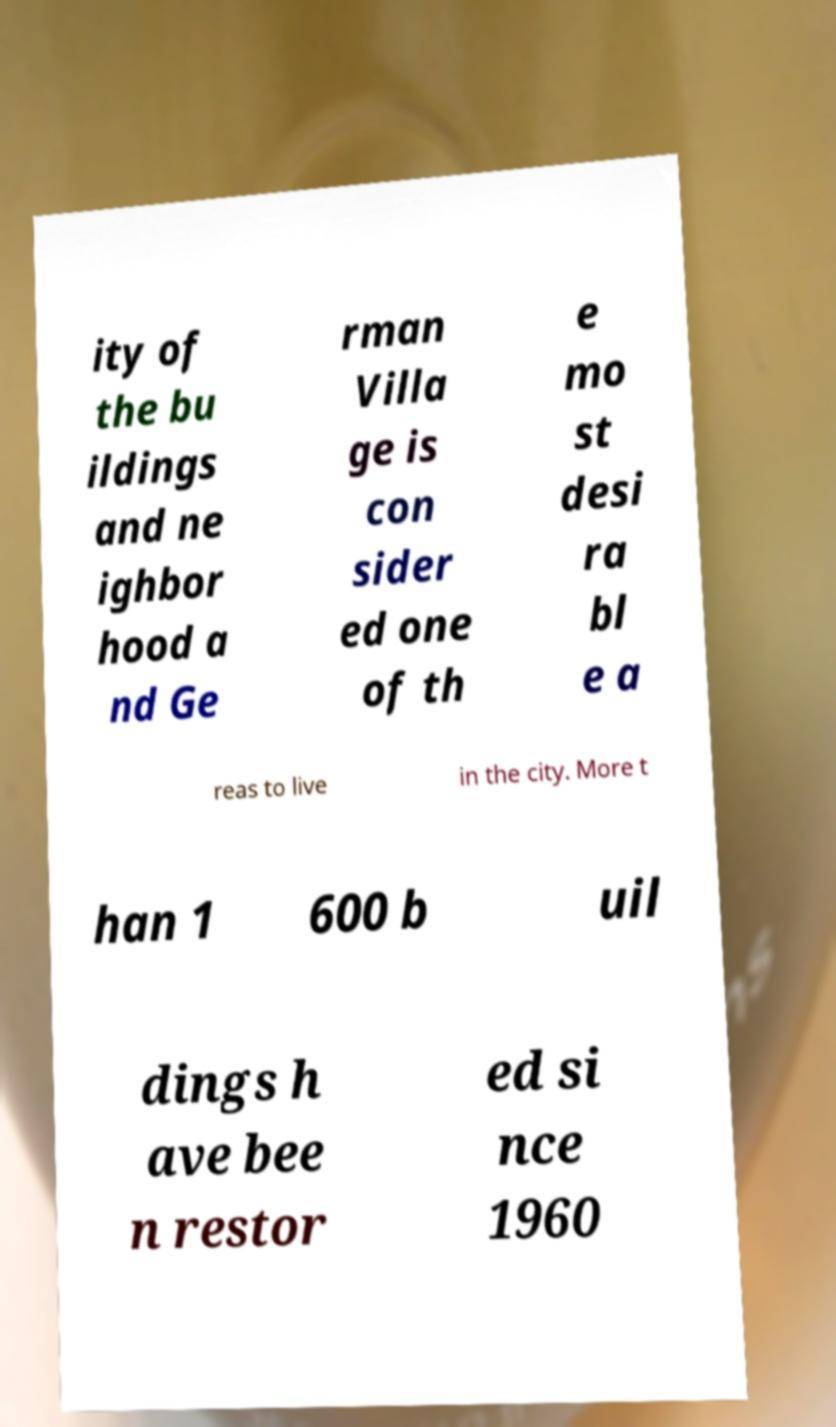Could you extract and type out the text from this image? ity of the bu ildings and ne ighbor hood a nd Ge rman Villa ge is con sider ed one of th e mo st desi ra bl e a reas to live in the city. More t han 1 600 b uil dings h ave bee n restor ed si nce 1960 